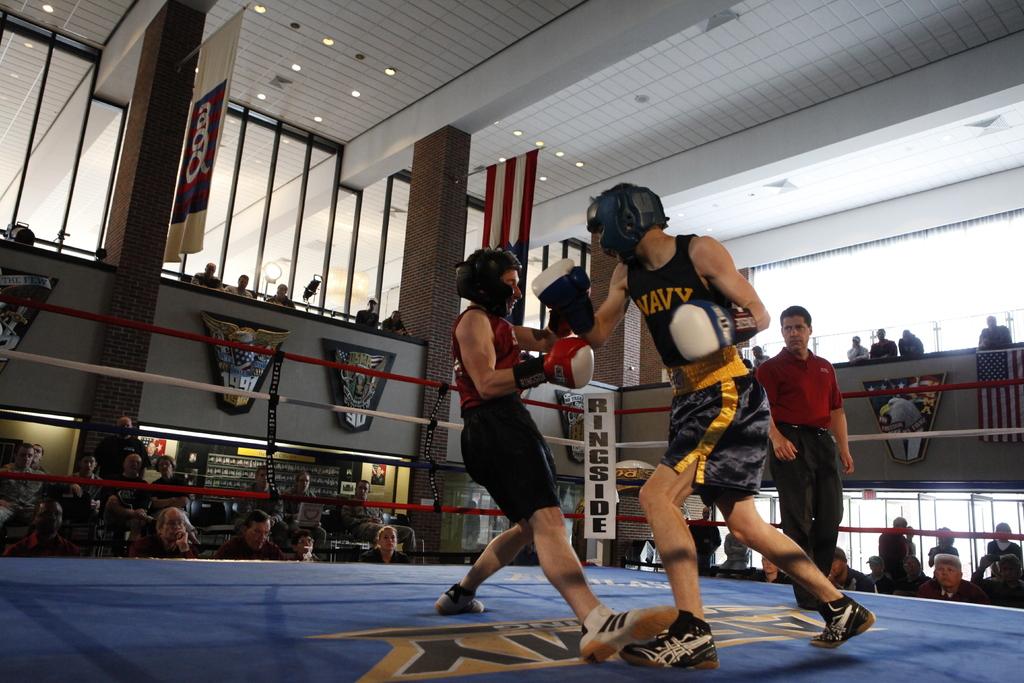Which military branch is named on the guy in blue's shirt?
Keep it short and to the point. Navy. What are these two men doing?
Provide a short and direct response. Answering does not require reading text in the image. 